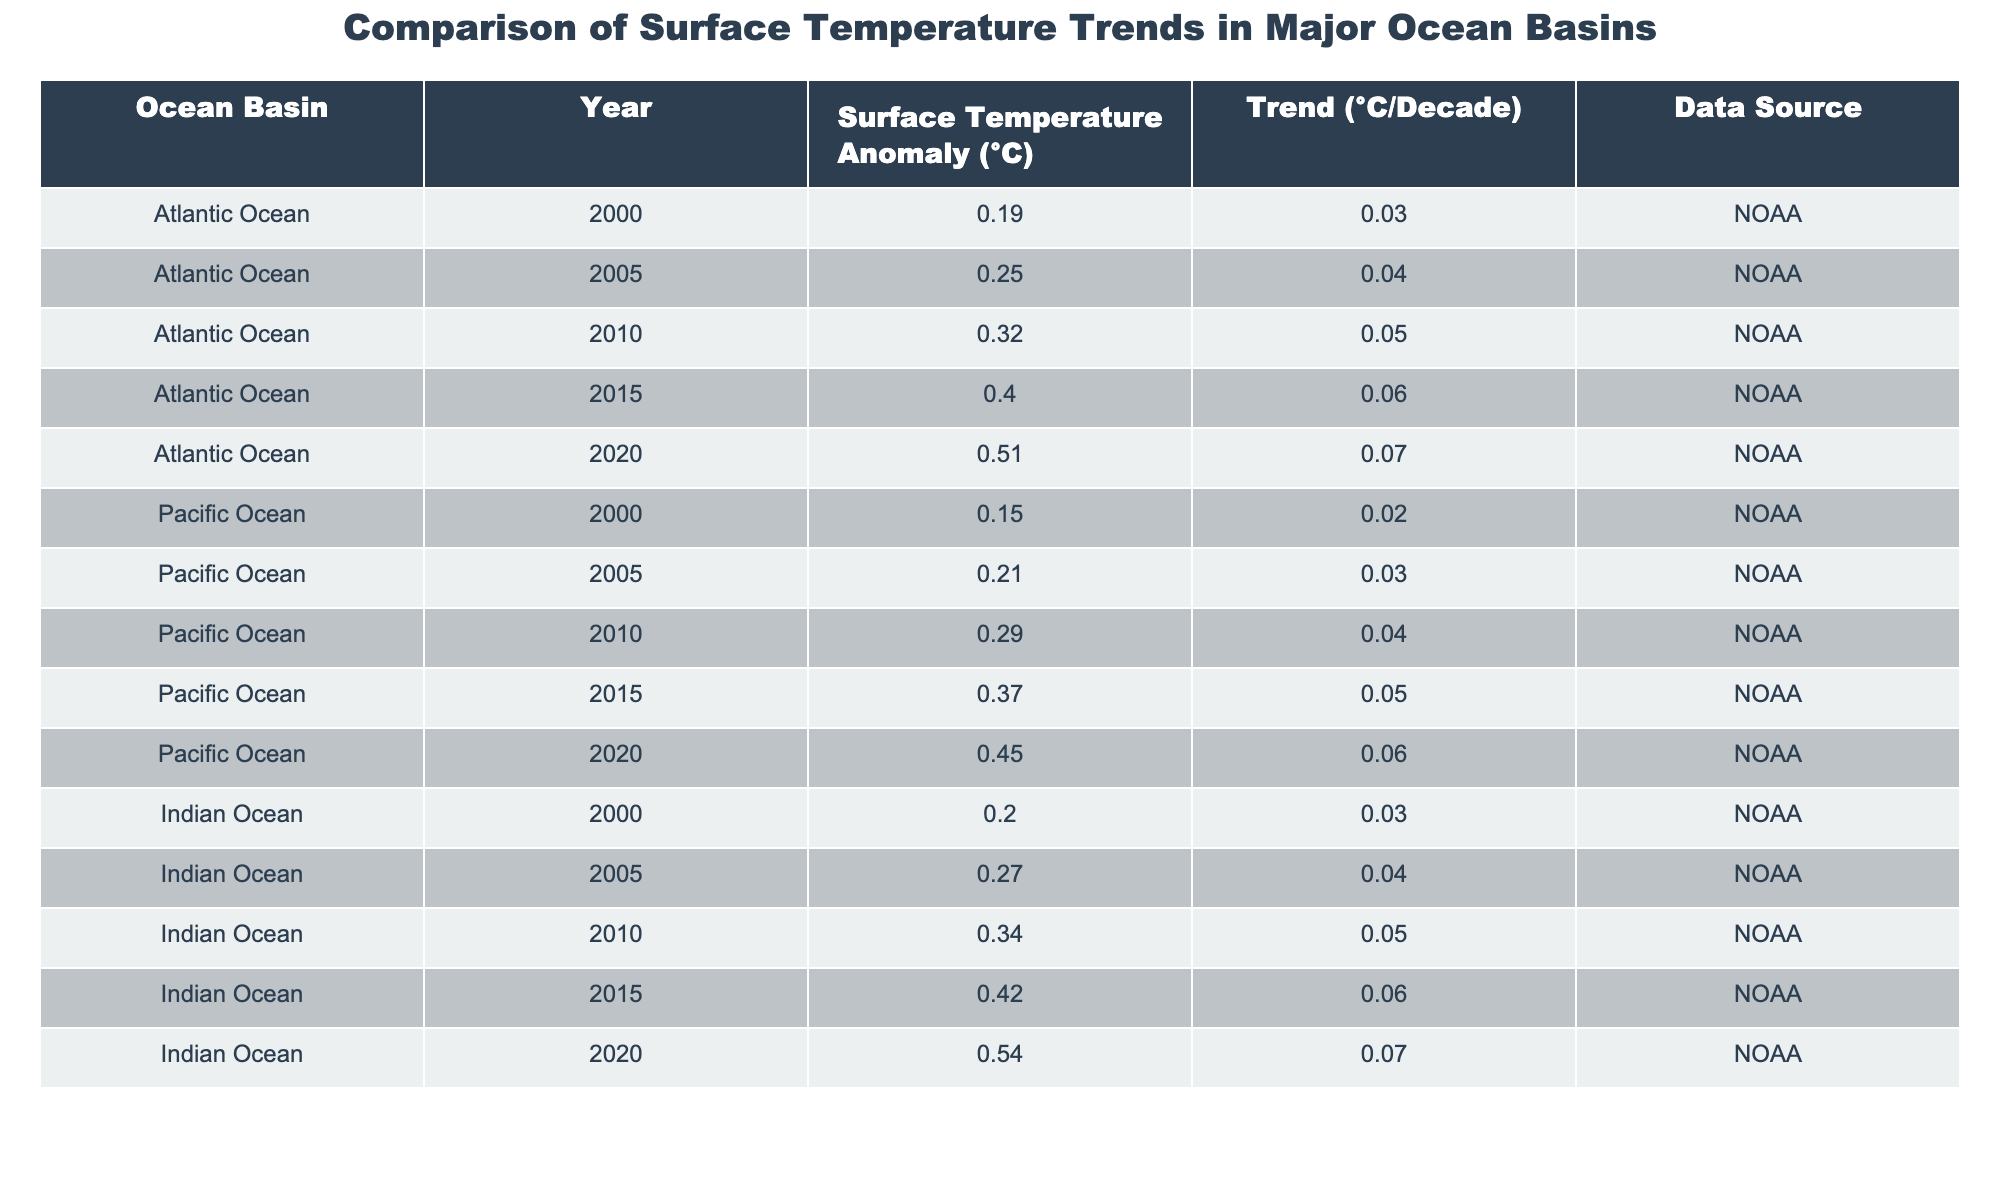What is the surface temperature anomaly of the Atlantic Ocean in 2020? Referring to the table, the value for the Atlantic Ocean in 2020 is found in the row corresponding to that specific year, which is 0.51 °C.
Answer: 0.51 °C What is the trend of surface temperature anomaly for the Pacific Ocean from 2000 to 2020? The trend for the Pacific Ocean can be calculated by subtracting the earliest year (0.15 °C in 2000) from the latest year (0.45 °C in 2020), giving us 0.45 - 0.15 = 0.30 °C over 20 years. The trend per decade is therefore 0.30/2 = 0.15 °C/decade.
Answer: 0.15 °C/decade Which ocean basin shows the highest temperature anomaly in 2015? By checking the table for the year 2015, the temperature anomalies are compared: Atlantic (0.40 °C), Pacific (0.37 °C), Indian (0.42 °C). The highest value is 0.42 °C for the Indian Ocean.
Answer: Indian Ocean How many ocean basins presented a temperature anomaly greater than 0.50 °C in 2020? Based on the 2020 data, only the Atlantic (0.51 °C) and Indian Ocean (0.54 °C) had values exceeding 0.50 °C. Thus, there are 2 ocean basins.
Answer: 2 What is the average surface temperature anomaly for the Indian Ocean from 2000 to 2020? The Indian Ocean values are 0.20 °C, 0.27 °C, 0.34 °C, 0.42 °C, and 0.54 °C. Adding these gives us 0.20 + 0.27 + 0.34 + 0.42 + 0.54 = 1.77 °C, divided by 5 data points gives an average of 1.77/5 = 0.354 °C.
Answer: 0.354 °C Is the trend of surface temperature anomaly in the Atlantic Ocean higher than in the Indian Ocean from 2000 to 2020? Analyzing the trends, the Atlantic Ocean has a trend of 0.07 °C/decade, while the Indian Ocean also has a trend of 0.07 °C/decade. Since both values are equal, the answer is no.
Answer: No What is the difference in the temperature anomaly between the Atlantic and Pacific Oceans in 2010? In 2010, the Atlantic Ocean had an anomaly of 0.32 °C, and the Pacific Ocean had an anomaly of 0.29 °C. The difference is calculated as 0.32 - 0.29 = 0.03 °C.
Answer: 0.03 °C Which ocean basin had the most significant increase in surface temperature anomaly from 2000 to 2020? Analyzing the increase for each ocean basin: Atlantic (0.51 - 0.19 = 0.32 °C), Pacific (0.45 - 0.15 = 0.30 °C), and Indian (0.54 - 0.20 = 0.34 °C). The highest increase is 0.34 °C for the Indian Ocean.
Answer: Indian Ocean 